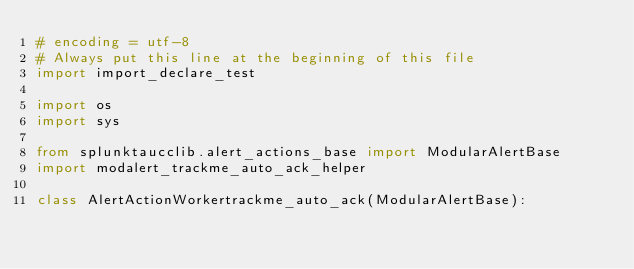<code> <loc_0><loc_0><loc_500><loc_500><_Python_># encoding = utf-8
# Always put this line at the beginning of this file
import import_declare_test

import os
import sys

from splunktaucclib.alert_actions_base import ModularAlertBase
import modalert_trackme_auto_ack_helper

class AlertActionWorkertrackme_auto_ack(ModularAlertBase):
</code> 